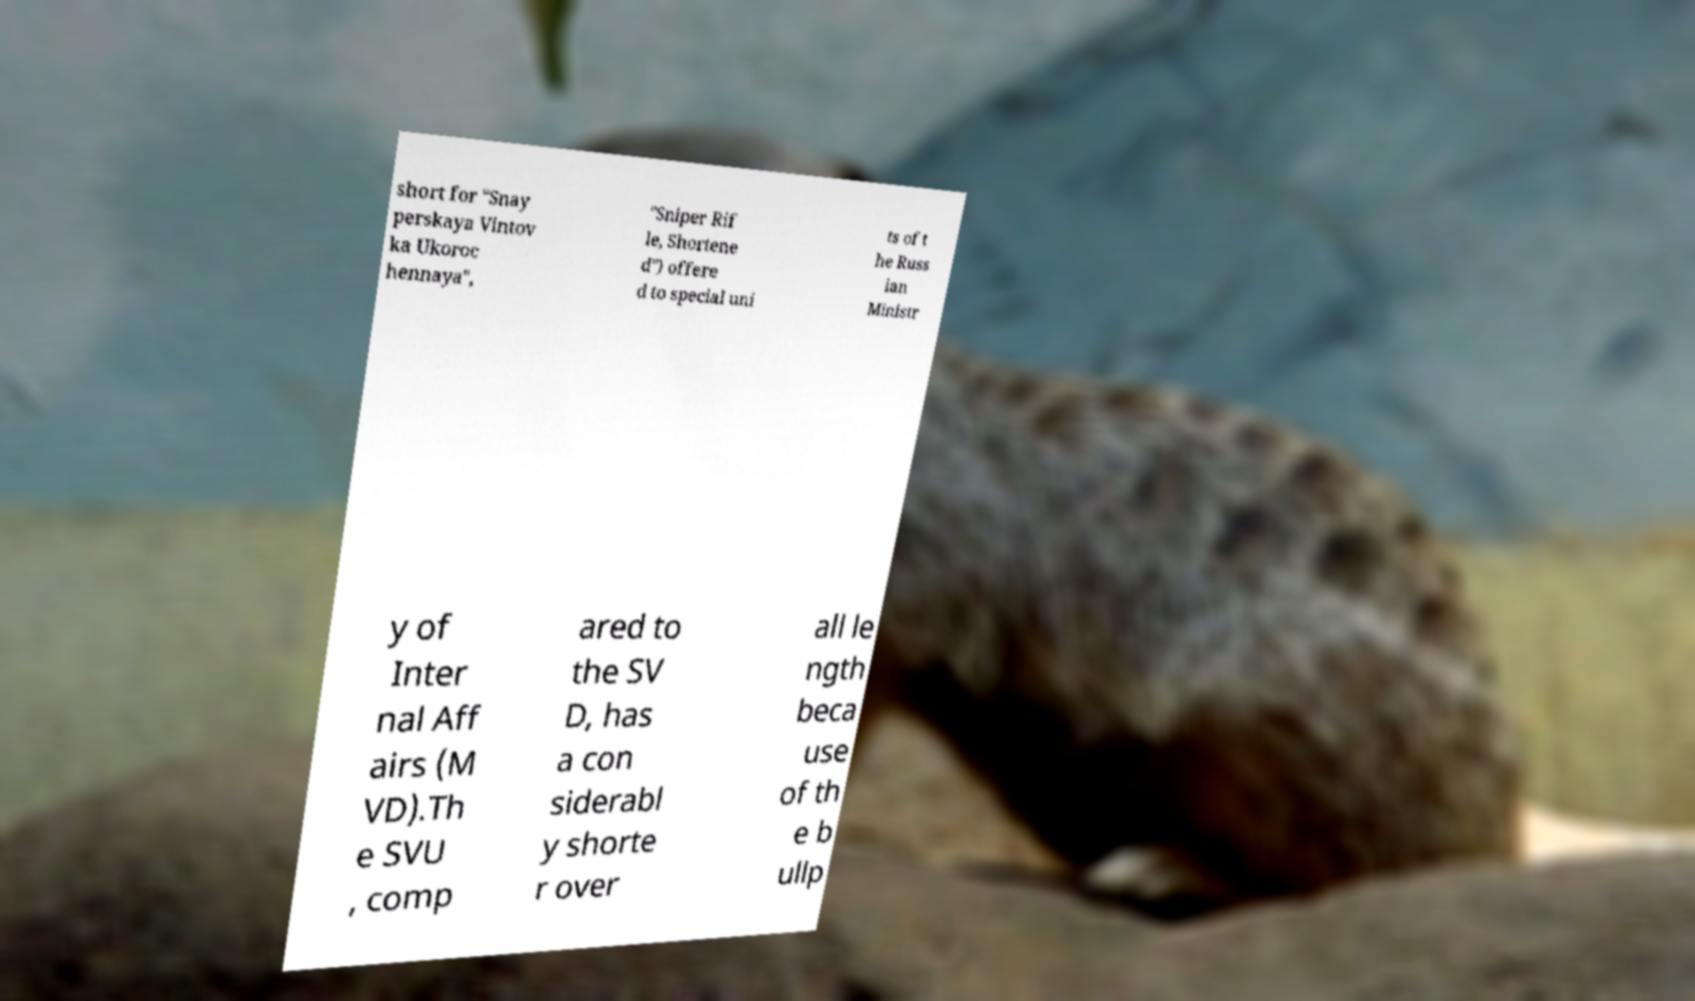I need the written content from this picture converted into text. Can you do that? short for "Snay perskaya Vintov ka Ukoroc hennaya", "Sniper Rif le, Shortene d") offere d to special uni ts of t he Russ ian Ministr y of Inter nal Aff airs (M VD).Th e SVU , comp ared to the SV D, has a con siderabl y shorte r over all le ngth beca use of th e b ullp 